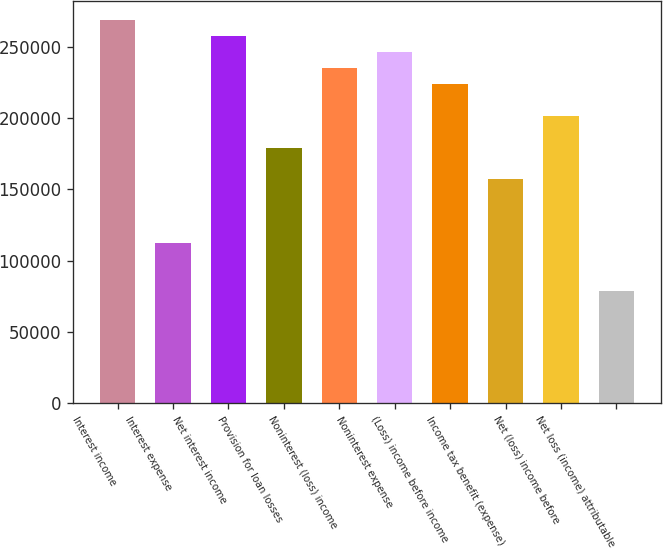<chart> <loc_0><loc_0><loc_500><loc_500><bar_chart><fcel>Interest income<fcel>Interest expense<fcel>Net interest income<fcel>Provision for loan losses<fcel>Noninterest (loss) income<fcel>Noninterest expense<fcel>(Loss) income before income<fcel>Income tax benefit (expense)<fcel>Net (loss) income before<fcel>Net loss (income) attributable<nl><fcel>269148<fcel>112145<fcel>257934<fcel>179432<fcel>235505<fcel>246719<fcel>224290<fcel>157003<fcel>201861<fcel>78501.5<nl></chart> 